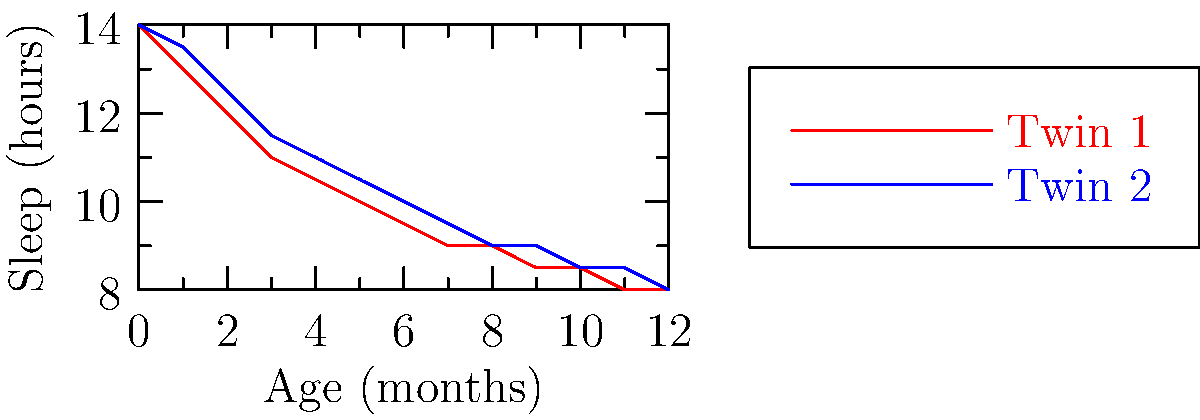Based on the line graph showing the sleep patterns of twins over their first year, during which month do both twins start sleeping the same number of hours per day? To determine when both twins start sleeping the same number of hours per day, we need to analyze the graph step-by-step:

1. The red line represents Twin 1's sleep pattern, while the blue line represents Twin 2's sleep pattern.
2. We need to find the point where these two lines intersect, as this is where both twins will have the same sleep duration.
3. Examining the graph from left to right:
   - At birth (0 months), both twins sleep for 14 hours.
   - From 1 to 11 months, Twin 2 consistently sleeps slightly more than Twin 1.
   - At 12 months (1 year), both lines converge at 8 hours of sleep.

4. The convergence at 12 months indicates that this is the first time since birth that both twins are sleeping the same number of hours per day.

Therefore, based on the graph, both twins start sleeping the same number of hours per day at 12 months of age.
Answer: 12 months 